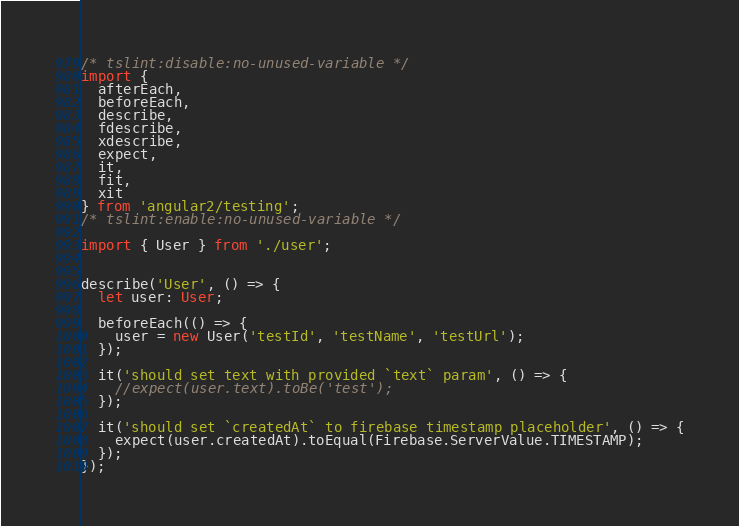Convert code to text. <code><loc_0><loc_0><loc_500><loc_500><_TypeScript_>/* tslint:disable:no-unused-variable */
import {
  afterEach,
  beforeEach,
  describe,
  fdescribe,
  xdescribe,
  expect,
  it,
  fit,
  xit
} from 'angular2/testing';
/* tslint:enable:no-unused-variable */

import { User } from './user';


describe('User', () => {
  let user: User;

  beforeEach(() => {
    user = new User('testId', 'testName', 'testUrl');
  });

  it('should set text with provided `text` param', () => {
    //expect(user.text).toBe('test');
  });

  it('should set `createdAt` to firebase timestamp placeholder', () => {
    expect(user.createdAt).toEqual(Firebase.ServerValue.TIMESTAMP);
  });
});
</code> 